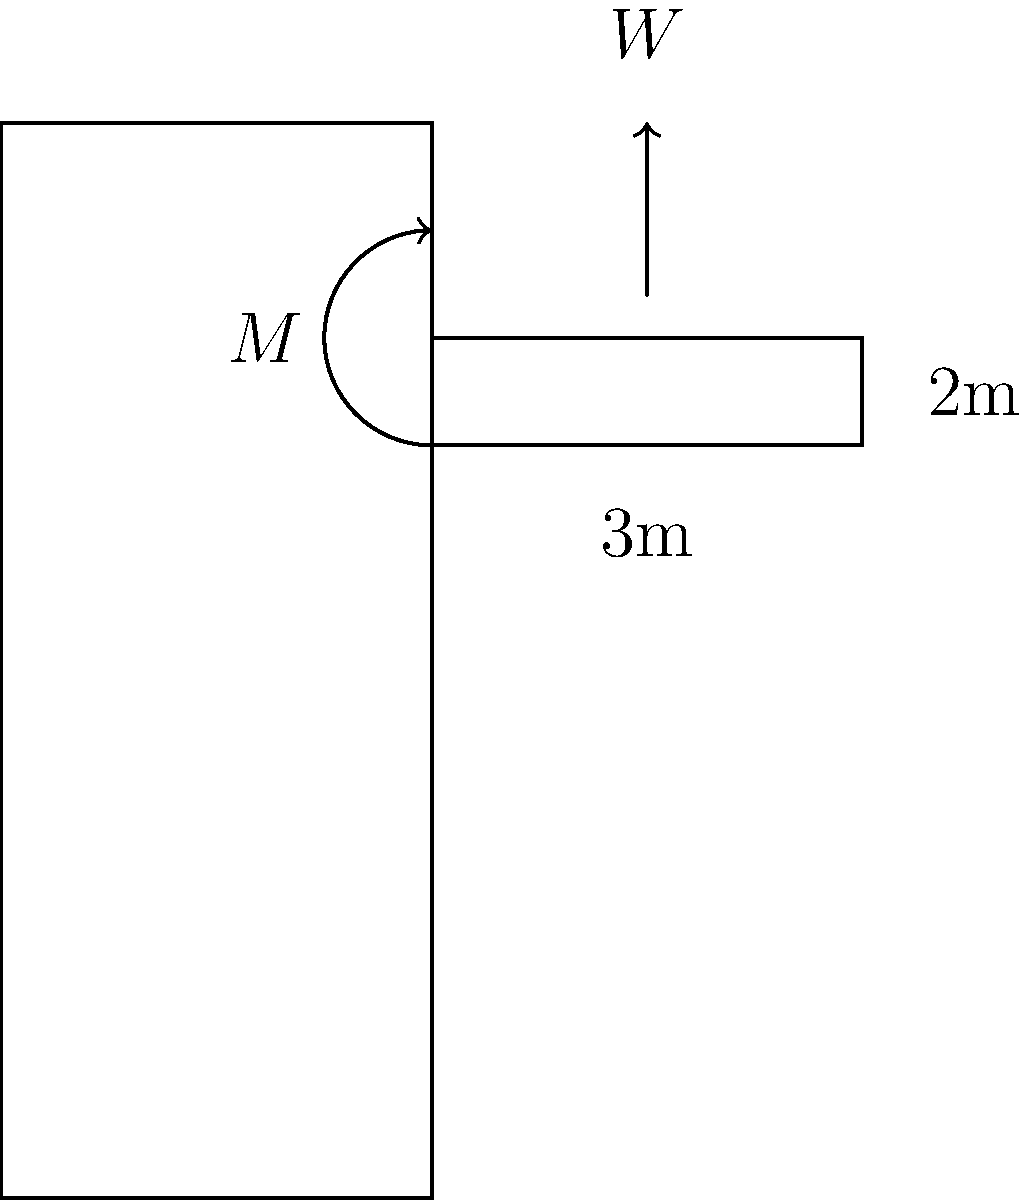A cantilevered balcony extends 3m from a building facade and has a width of 2m. The balcony's structural design allows for a maximum bending moment of 45 kNm at the connection to the building. Assuming a uniform load distribution and a safety factor of 1.5, what is the maximum allowable weight for plants and soil that can be placed on this balcony garden? To solve this problem, we'll follow these steps:

1) First, let's identify the given information:
   - Balcony length (L) = 3m
   - Balcony width (W) = 2m
   - Maximum bending moment (M) = 45 kNm
   - Safety factor (SF) = 1.5

2) The maximum allowable bending moment considering the safety factor is:
   $$M_{allowable} = \frac{M}{SF} = \frac{45 \text{ kNm}}{1.5} = 30 \text{ kNm}$$

3) For a uniformly distributed load on a cantilever, the bending moment at the support is given by:
   $$M = \frac{wL^2}{2}$$
   where w is the uniform load per unit length.

4) Rearranging this equation to solve for w:
   $$w = \frac{2M}{L^2} = \frac{2 \times 30 \text{ kNm}}{(3\text{ m})^2} = 6.67 \text{ kN/m}$$

5) This is the allowable load per unit length. To find the total allowable load (W), we multiply by the length:
   $$W = w \times L = 6.67 \text{ kN/m} \times 3\text{ m} = 20 \text{ kN}$$

6) To convert this to weight, we divide by gravitational acceleration (g ≈ 9.81 m/s²):
   $$\text{Weight} = \frac{W}{g} = \frac{20 \text{ kN}}{9.81 \text{ m/s}^2} \approx 2,039 \text{ kg}$$

Therefore, the maximum allowable weight for plants and soil on this balcony garden is approximately 2,039 kg.
Answer: 2,039 kg 